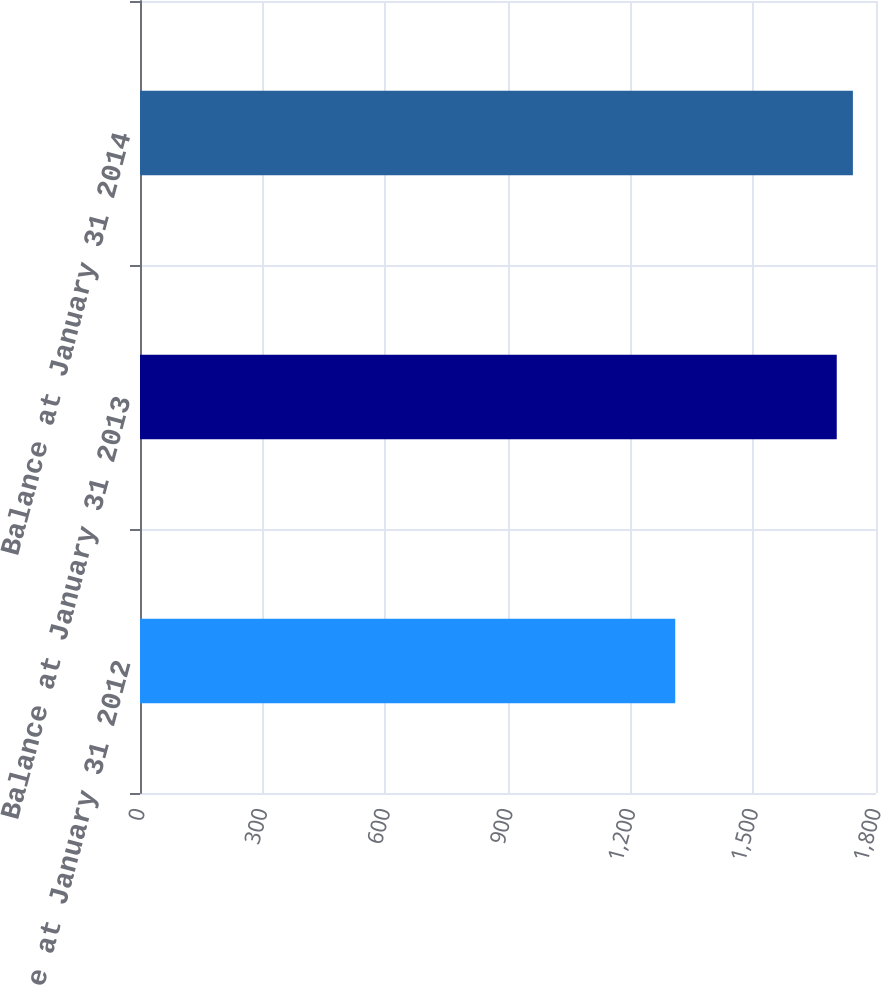<chart> <loc_0><loc_0><loc_500><loc_500><bar_chart><fcel>Balance at January 31 2012<fcel>Balance at January 31 2013<fcel>Balance at January 31 2014<nl><fcel>1309<fcel>1704<fcel>1743.5<nl></chart> 